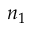Convert formula to latex. <formula><loc_0><loc_0><loc_500><loc_500>n _ { 1 }</formula> 